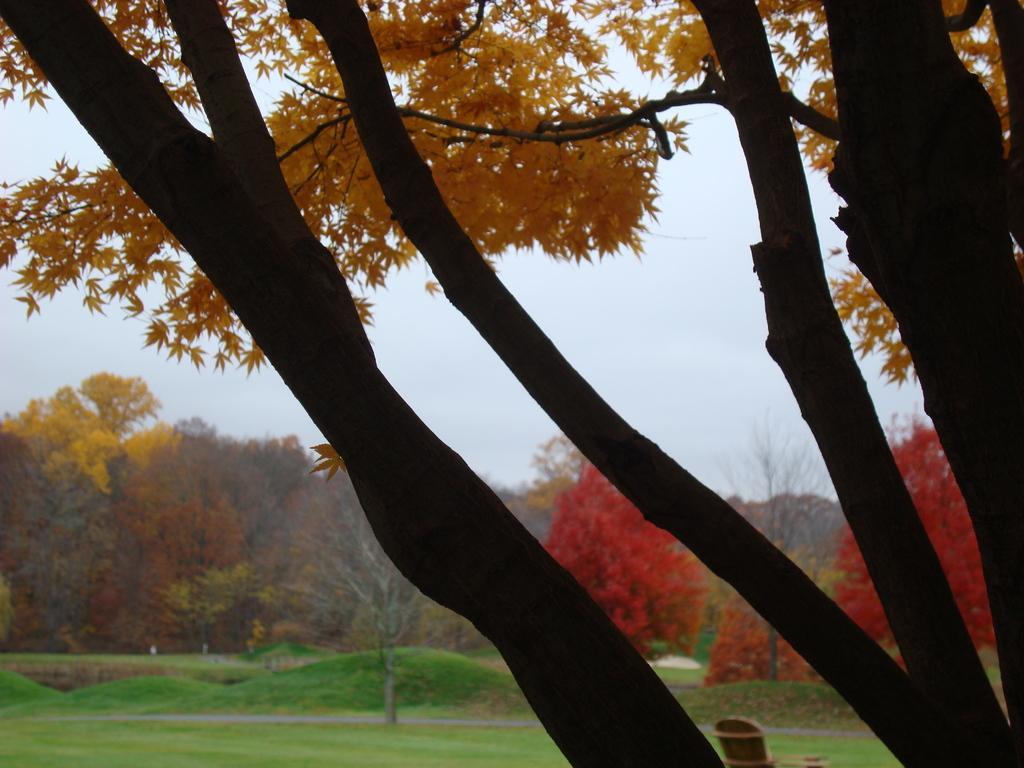Describe this image in one or two sentences. In the picture I can see trees and the grass. In the background I can see the sky. 